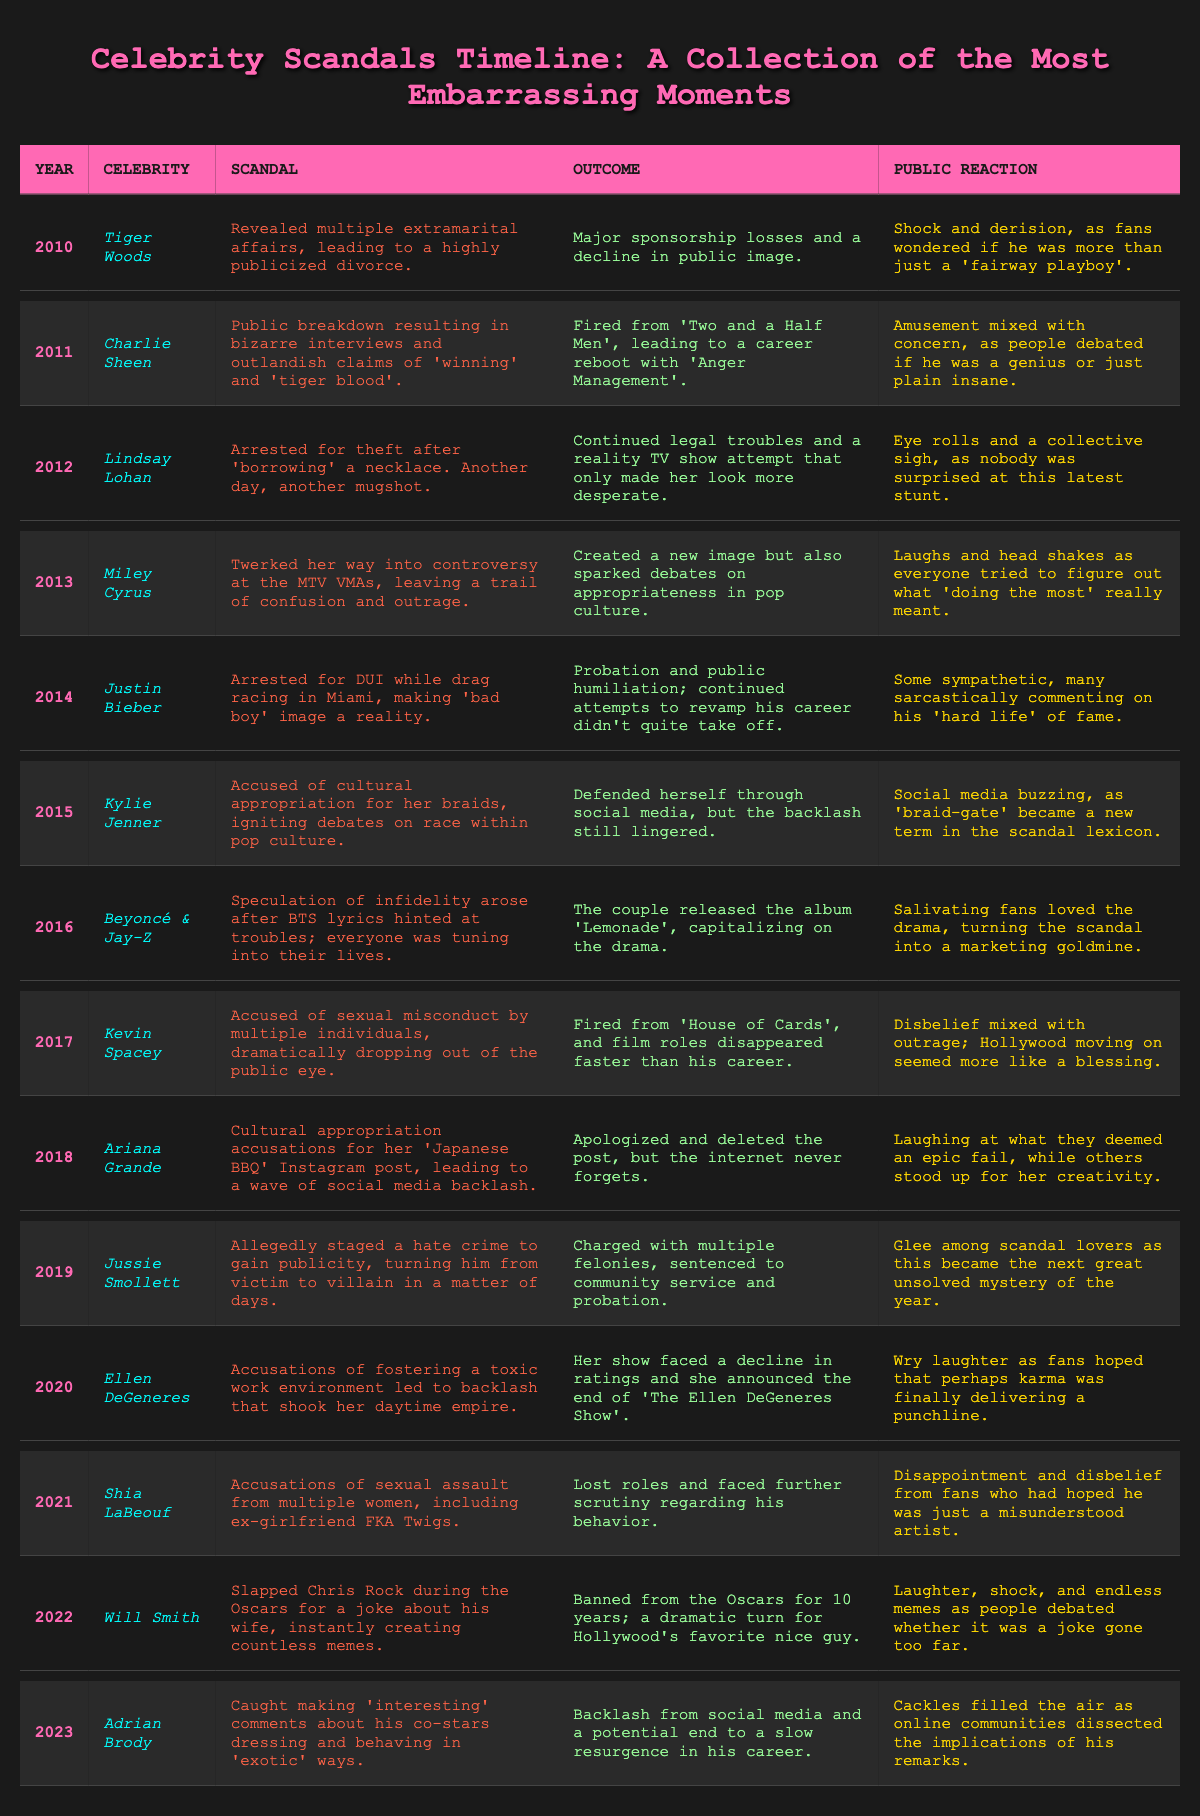What scandal did Tiger Woods face in 2010? The table states that Tiger Woods was revealed to have multiple extramarital affairs, leading to a highly publicized divorce.
Answer: Multiple extramarital affairs What was the public reaction to Lindsay Lohan's 2012 scandal? According to the table, the public reaction included eye rolls and a collective sigh, indicating that nobody was surprised by her arrest.
Answer: Eye rolls and a collective sigh How many years passed between Charlie Sheen's scandal and Will Smith's slap incident? Charlie Sheen's scandal occurred in 2011 and Will Smith's occurred in 2022. The years between them are: 2022 - 2011 = 11 years.
Answer: 11 years Which celebrity had a scandal involving accusations of fostering a toxic work environment? The table indicates that Ellen DeGeneres was accused of fostering a toxic work environment, leading to backlash against her show.
Answer: Ellen DeGeneres Did any scandals lead to bans from events for the celebrities involved? Yes, the table shows that Will Smith was banned from the Oscars for 10 years due to his scandal.
Answer: Yes What is the general sentiment towards Justin Bieber's scandal in 2014? The table mentions that reactions were mixed, with some being sympathetic and many sarcastically commenting on his tailspin into public humiliation.
Answer: Mixed reactions; some sympathetic, many sarcastic Which two celebrities mentioned infidelity in their scandals? The table shows that both Beyoncé & Jay-Z and Tiger Woods dealt with infidelity rumors in their scandals, as Beyoncé & Jay-Z faced speculation and Tiger Woods revealed affairs.
Answer: Beyoncé & Jay-Z and Tiger Woods How did the public respond to the accusations against Kevin Spacey in 2017? The table notes that the public reaction included disbelief mixed with outrage at the accusations against him, indicating a strong emotional response.
Answer: Disbelief mixed with outrage What notable outcome resulted from the public breakdown of Charlie Sheen in 2011? The table indicates that Charlie Sheen was fired from 'Two and a Half Men', which was a significant consequence of his public breakdown.
Answer: Fired from 'Two and a Half Men' In which year did Jussie Smollett stage a hate crime, and what was the public reaction? The table states that Jussie Smollett's scandal occurred in 2019, and the public reacted with glee as it turned into a major scandal of the year.
Answer: 2019; public reaction was glee 